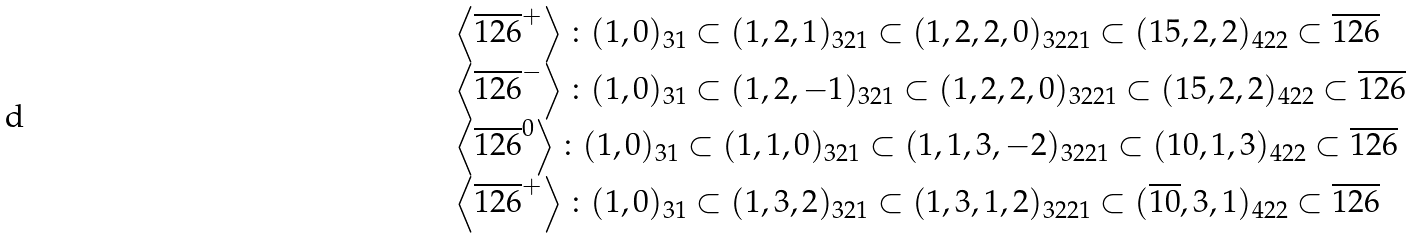<formula> <loc_0><loc_0><loc_500><loc_500>\begin{array} { l } { { \left < \overline { 1 2 6 } ^ { + } \right > \colon ( 1 , 0 ) _ { 3 1 } \subset ( 1 , 2 , 1 ) _ { 3 2 1 } \subset ( 1 , 2 , 2 , 0 ) _ { 3 2 2 1 } \subset ( 1 5 , 2 , 2 ) _ { 4 2 2 } \subset \overline { 1 2 6 } } } \\ { { \left < \overline { 1 2 6 } ^ { - } \right > \colon ( 1 , 0 ) _ { 3 1 } \subset ( 1 , 2 , - 1 ) _ { 3 2 1 } \subset ( 1 , 2 , 2 , 0 ) _ { 3 2 2 1 } \subset ( 1 5 , 2 , 2 ) _ { 4 2 2 } \subset \overline { 1 2 6 } } } \\ { { \left < \overline { 1 2 6 } ^ { 0 } \right > \colon ( 1 , 0 ) _ { 3 1 } \subset ( 1 , 1 , 0 ) _ { 3 2 1 } \subset ( 1 , 1 , 3 , - 2 ) _ { 3 2 2 1 } \subset ( 1 0 , 1 , 3 ) _ { 4 2 2 } \subset \overline { 1 2 6 } } } \\ { { \left < \overline { 1 2 6 } ^ { + } \right > \colon ( 1 , 0 ) _ { 3 1 } \subset ( 1 , 3 , 2 ) _ { 3 2 1 } \subset ( 1 , 3 , 1 , 2 ) _ { 3 2 2 1 } \subset ( \overline { 1 0 } , 3 , 1 ) _ { 4 2 2 } \subset \overline { 1 2 6 } } } \end{array}</formula> 